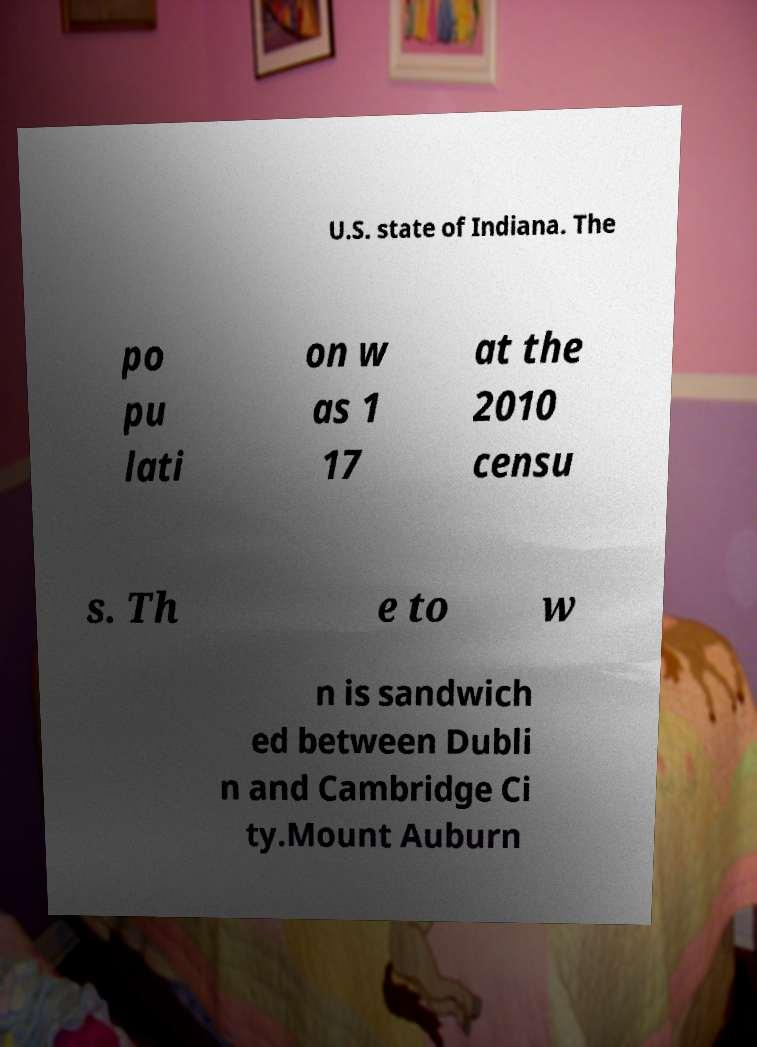For documentation purposes, I need the text within this image transcribed. Could you provide that? U.S. state of Indiana. The po pu lati on w as 1 17 at the 2010 censu s. Th e to w n is sandwich ed between Dubli n and Cambridge Ci ty.Mount Auburn 